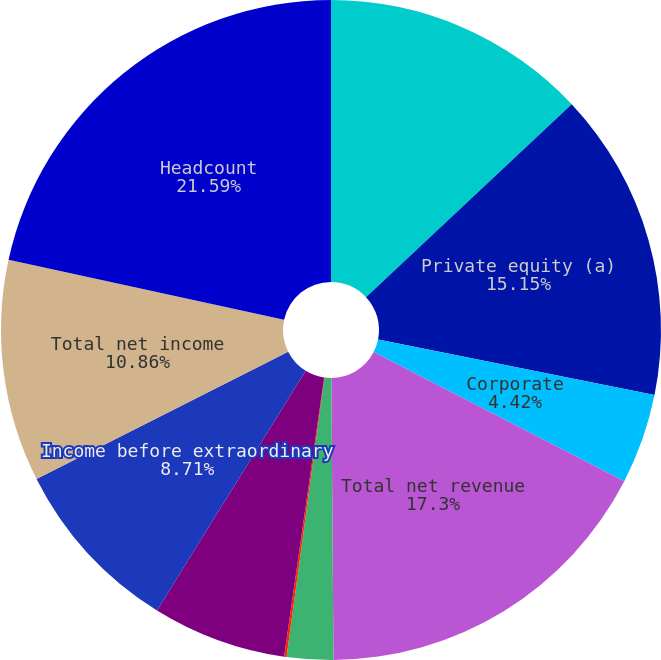Convert chart to OTSL. <chart><loc_0><loc_0><loc_500><loc_500><pie_chart><fcel>(in millions except headcount)<fcel>Private equity (a)<fcel>Corporate<fcel>Total net revenue<fcel>Corporate (b)(c)<fcel>Merger-related items (d)<fcel>Income (loss) from continuing<fcel>Income before extraordinary<fcel>Total net income<fcel>Headcount<nl><fcel>13.01%<fcel>15.15%<fcel>4.42%<fcel>17.3%<fcel>2.27%<fcel>0.12%<fcel>6.57%<fcel>8.71%<fcel>10.86%<fcel>21.59%<nl></chart> 